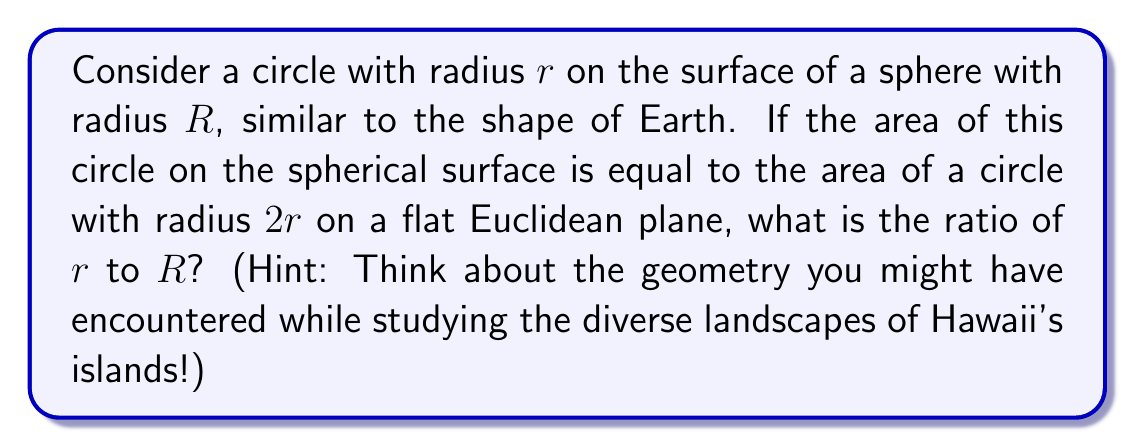Provide a solution to this math problem. Let's approach this step-by-step:

1) The area of a circle on a flat Euclidean plane is given by:
   $$A_{E} = \pi r^2$$

2) For the circle on the spherical surface, we need to use the formula for the area of a spherical cap:
   $$A_{S} = 2\pi R^2(1 - \cos(\theta))$$
   where $\theta$ is the central angle in radians.

3) The relationship between the arc length (which is the circumference of our circle on the sphere), the radius of the sphere, and the central angle is:
   $$2\pi r = R\theta$$

4) Solving for $\theta$:
   $$\theta = \frac{2\pi r}{R}$$

5) Substituting this into our spherical cap area formula:
   $$A_{S} = 2\pi R^2(1 - \cos(\frac{2\pi r}{R}))$$

6) Now, we're told that this area is equal to the area of a circle with radius $2r$ on a flat plane:
   $$2\pi R^2(1 - \cos(\frac{2\pi r}{R})) = \pi (2r)^2 = 4\pi r^2$$

7) Simplifying:
   $$2R^2(1 - \cos(\frac{2\pi r}{R})) = 4r^2$$

8) Using the small-angle approximation $\cos(x) \approx 1 - \frac{x^2}{2}$ for small $x$:
   $$2R^2(1 - (1 - \frac{(\frac{2\pi r}{R})^2}{2})) = 4r^2$$

9) Simplifying:
   $$2R^2(\frac{2\pi^2 r^2}{R^2}) = 4r^2$$

10) Cancelling terms:
    $$4\pi^2 r^2 = 4r^2$$

11) Solving for $\pi$:
    $$\pi = 1$$

12) This is only true when $r$ is very small compared to $R$, specifically when:
    $$\frac{r}{R} = \frac{1}{\pi}$$

This ratio ensures that the small-angle approximation we used is valid.
Answer: $\frac{r}{R} = \frac{1}{\pi}$ 